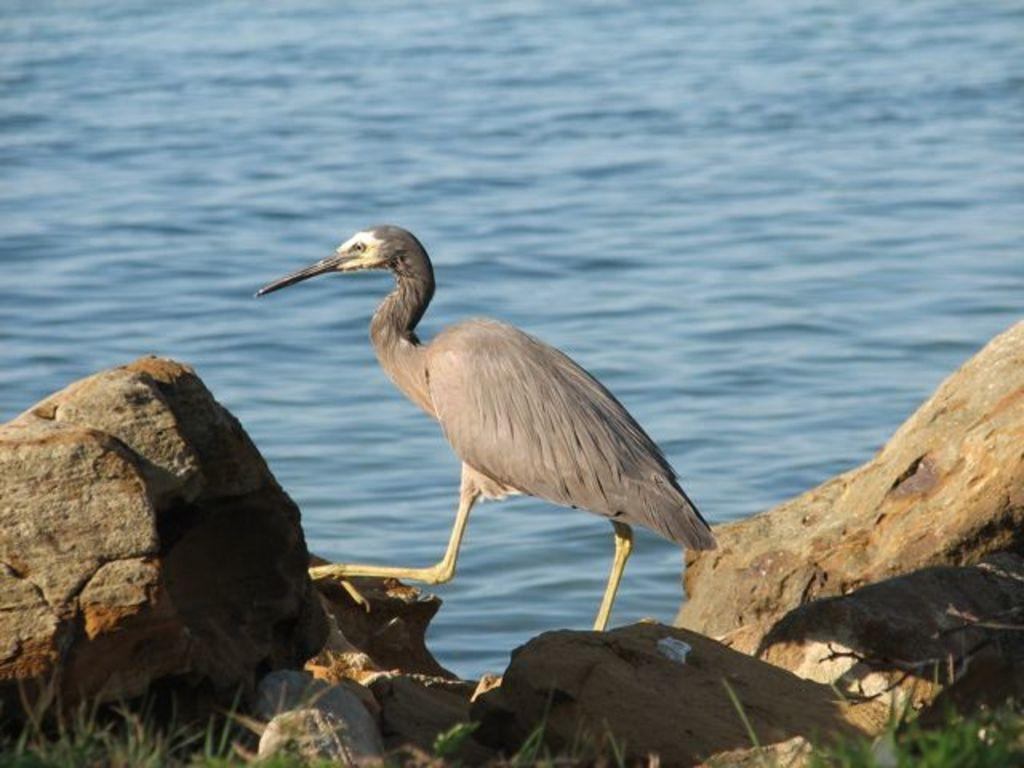What type of animal can be seen in the image? There is a bird in the image. Can you describe the bird's beak? The bird has a sharp beak. What is located at the bottom of the image? There are rocks and green grass at the bottom of the image. What can be seen in the background of the image? There is water visible in the background of the image. How does the bird use the gun in the image? There is no gun present in the image; it only features a bird with a sharp beak. How does the bear contribute to the increase in the bird's population in the image? There is no bear present in the image, and therefore no such interaction can be observed. 